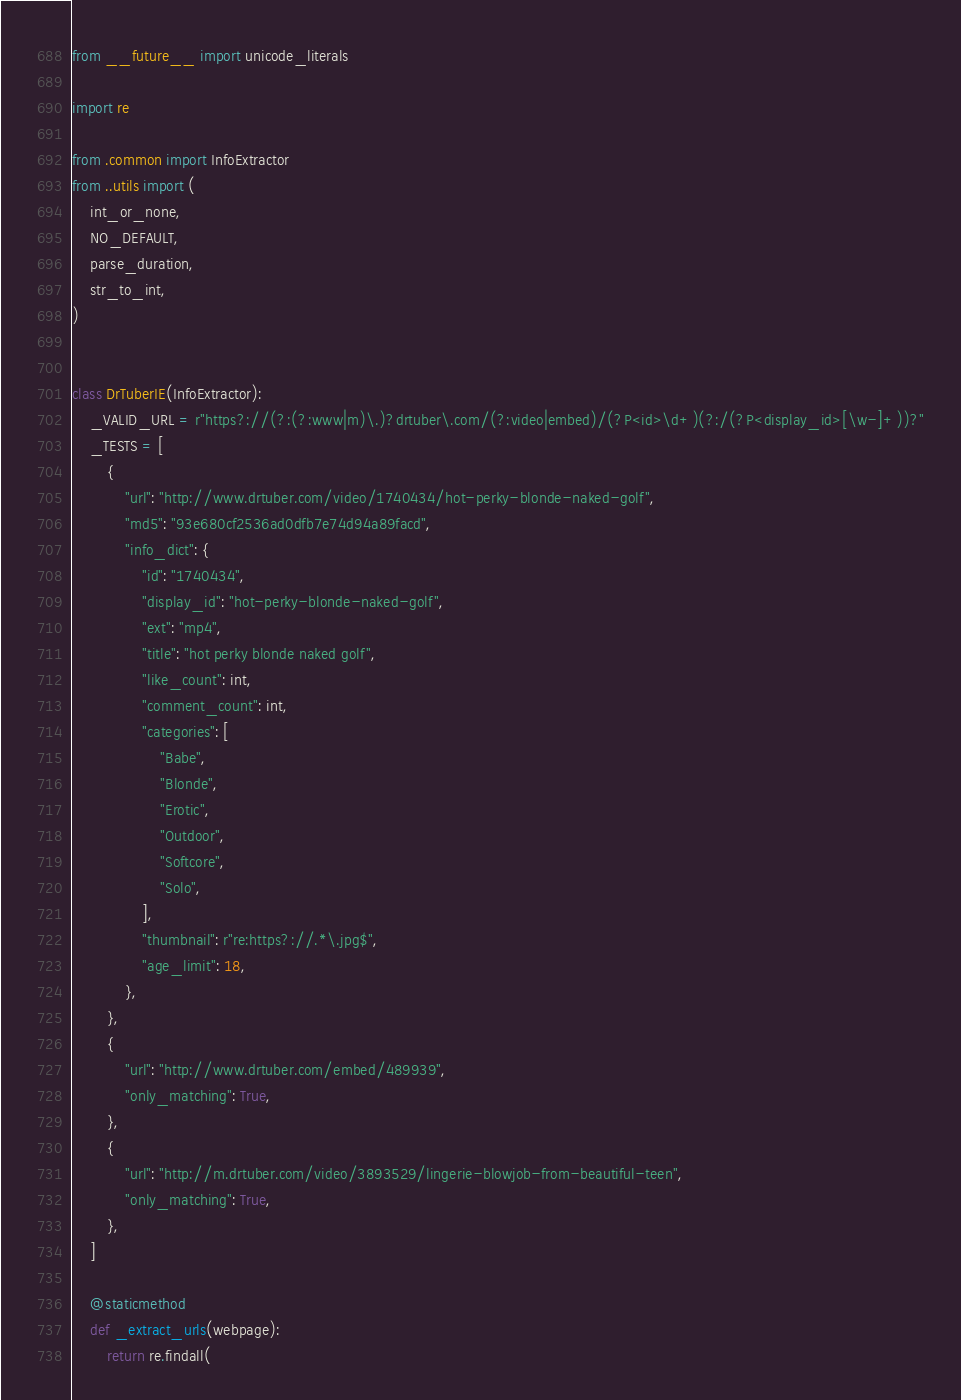<code> <loc_0><loc_0><loc_500><loc_500><_Python_>from __future__ import unicode_literals

import re

from .common import InfoExtractor
from ..utils import (
    int_or_none,
    NO_DEFAULT,
    parse_duration,
    str_to_int,
)


class DrTuberIE(InfoExtractor):
    _VALID_URL = r"https?://(?:(?:www|m)\.)?drtuber\.com/(?:video|embed)/(?P<id>\d+)(?:/(?P<display_id>[\w-]+))?"
    _TESTS = [
        {
            "url": "http://www.drtuber.com/video/1740434/hot-perky-blonde-naked-golf",
            "md5": "93e680cf2536ad0dfb7e74d94a89facd",
            "info_dict": {
                "id": "1740434",
                "display_id": "hot-perky-blonde-naked-golf",
                "ext": "mp4",
                "title": "hot perky blonde naked golf",
                "like_count": int,
                "comment_count": int,
                "categories": [
                    "Babe",
                    "Blonde",
                    "Erotic",
                    "Outdoor",
                    "Softcore",
                    "Solo",
                ],
                "thumbnail": r"re:https?://.*\.jpg$",
                "age_limit": 18,
            },
        },
        {
            "url": "http://www.drtuber.com/embed/489939",
            "only_matching": True,
        },
        {
            "url": "http://m.drtuber.com/video/3893529/lingerie-blowjob-from-beautiful-teen",
            "only_matching": True,
        },
    ]

    @staticmethod
    def _extract_urls(webpage):
        return re.findall(</code> 